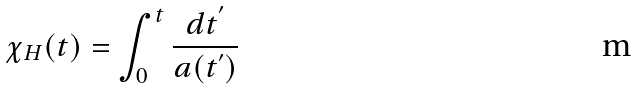Convert formula to latex. <formula><loc_0><loc_0><loc_500><loc_500>\chi _ { H } ( t ) = \int _ { 0 } ^ { t } \frac { d t ^ { ^ { \prime } } } { a ( t ^ { ^ { \prime } } ) }</formula> 